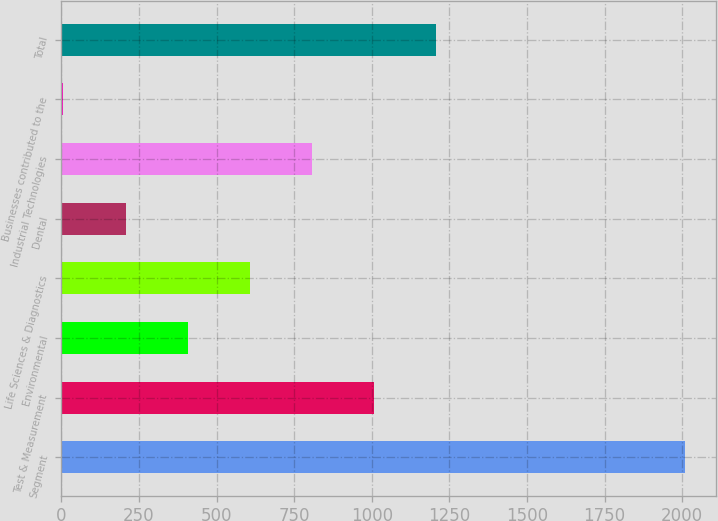Convert chart to OTSL. <chart><loc_0><loc_0><loc_500><loc_500><bar_chart><fcel>Segment<fcel>Test & Measurement<fcel>Environmental<fcel>Life Sciences & Diagnostics<fcel>Dental<fcel>Industrial Technologies<fcel>Businesses contributed to the<fcel>Total<nl><fcel>2008<fcel>1007.5<fcel>407.2<fcel>607.3<fcel>207.1<fcel>807.4<fcel>7<fcel>1207.6<nl></chart> 